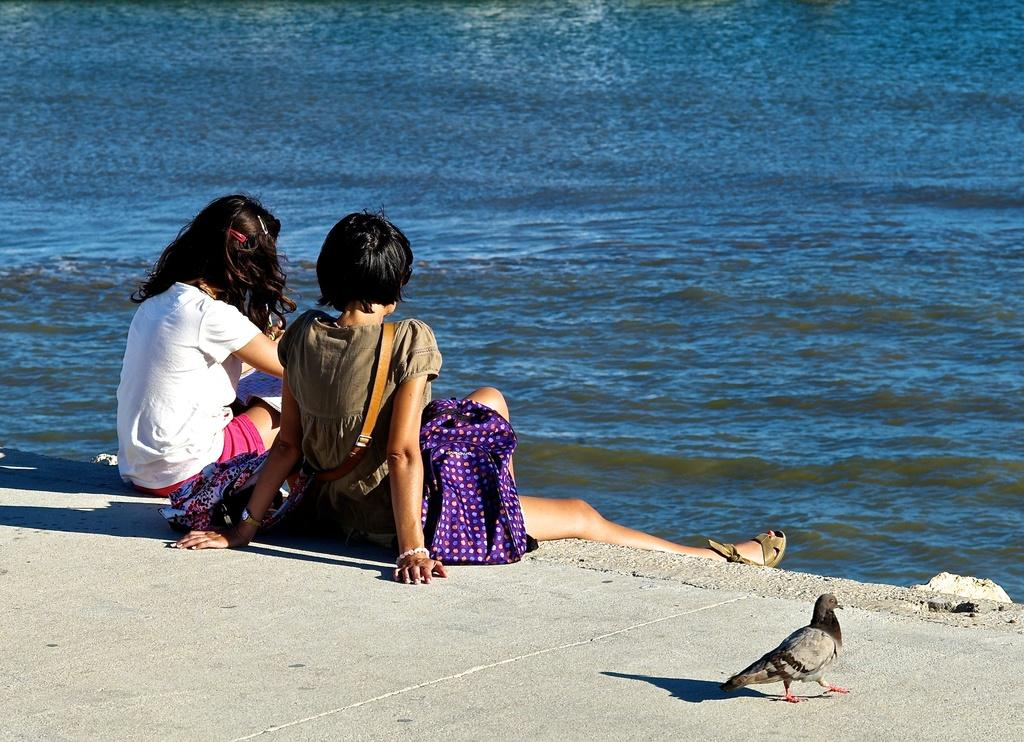How many people are in the image? There are two girls in the image. What are the girls doing in the image? The girls are sitting on a concrete slab. What type of animal can be seen in the image? There is a pigeon in the image. What can be seen in the background of the image? There is blue water visible in the background of the image. What type of transport can be seen in the image? There is no transport visible in the image; it features two girls sitting on a concrete slab, a pigeon, and blue water in the background. What is the texture of the girls' tongues in the image? There is no information about the girls' tongues in the image, so it cannot be determined. 